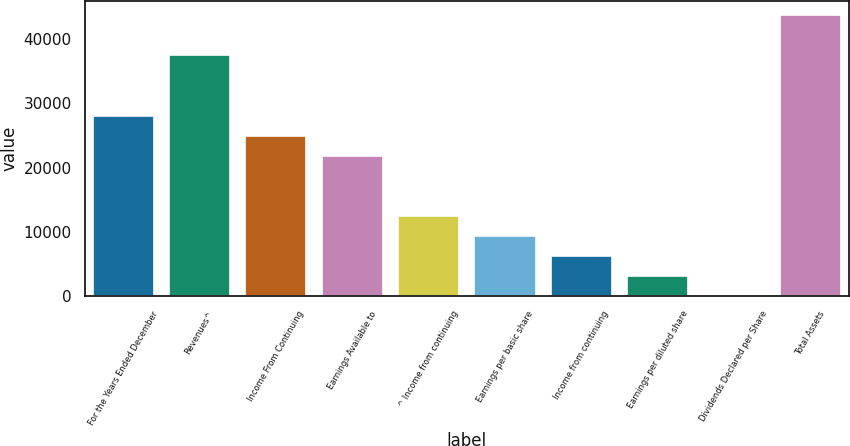Convert chart. <chart><loc_0><loc_0><loc_500><loc_500><bar_chart><fcel>For the Years Ended December<fcel>Revenues^<fcel>Income From Continuing<fcel>Earnings Available to<fcel>^ Income from continuing<fcel>Earnings per basic share<fcel>Income from continuing<fcel>Earnings per diluted share<fcel>Dividends Declared per Share<fcel>Total Assets<nl><fcel>28076.6<fcel>37434.8<fcel>24957.2<fcel>21837.8<fcel>12479.5<fcel>9360.1<fcel>6240.69<fcel>3121.27<fcel>1.85<fcel>43673.7<nl></chart> 